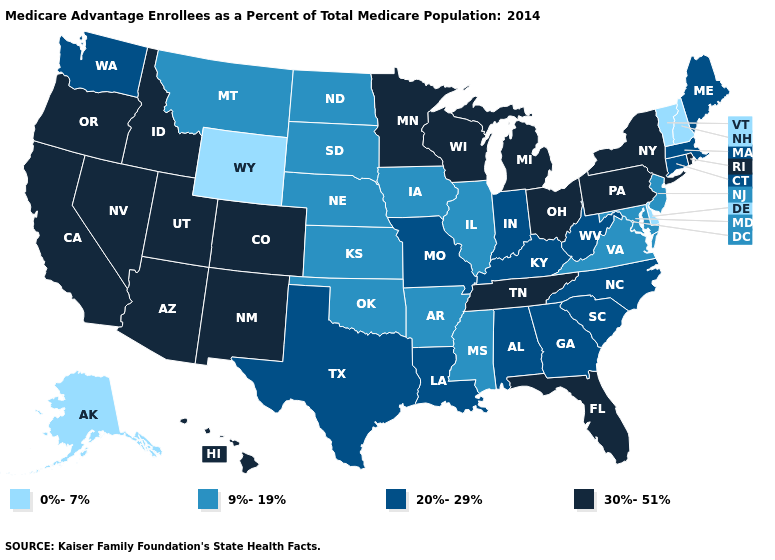What is the lowest value in states that border Oregon?
Answer briefly. 20%-29%. How many symbols are there in the legend?
Be succinct. 4. What is the highest value in the USA?
Quick response, please. 30%-51%. What is the lowest value in the Northeast?
Concise answer only. 0%-7%. Does Idaho have the highest value in the West?
Answer briefly. Yes. What is the highest value in the USA?
Answer briefly. 30%-51%. Name the states that have a value in the range 9%-19%?
Quick response, please. Arkansas, Iowa, Illinois, Kansas, Maryland, Mississippi, Montana, North Dakota, Nebraska, New Jersey, Oklahoma, South Dakota, Virginia. What is the value of Hawaii?
Keep it brief. 30%-51%. Does the map have missing data?
Answer briefly. No. What is the lowest value in the South?
Give a very brief answer. 0%-7%. What is the lowest value in states that border Pennsylvania?
Write a very short answer. 0%-7%. Among the states that border New Mexico , does Arizona have the lowest value?
Give a very brief answer. No. Does Massachusetts have the lowest value in the Northeast?
Concise answer only. No. Does Florida have the highest value in the USA?
Answer briefly. Yes. Does Connecticut have a higher value than Illinois?
Give a very brief answer. Yes. 